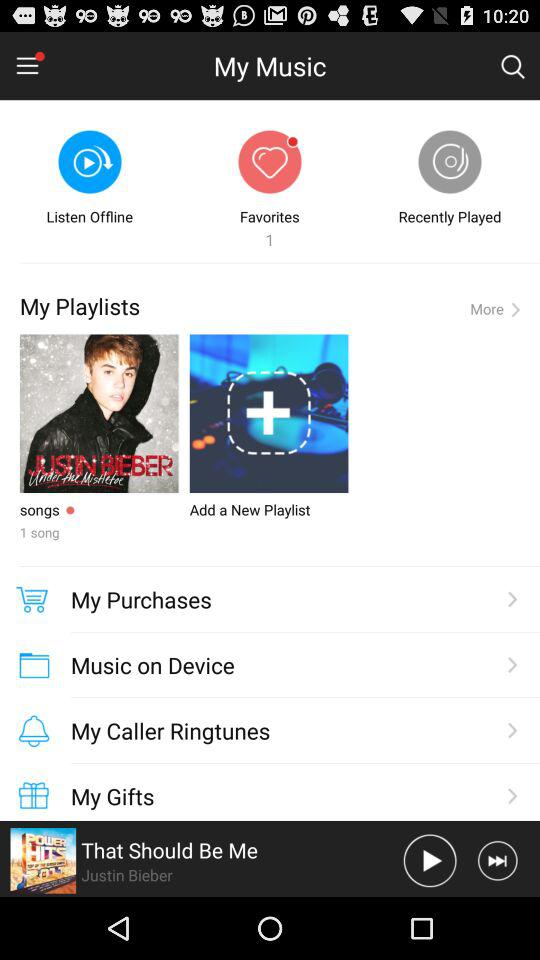What is the count of "Favorites"? The count is 1. 